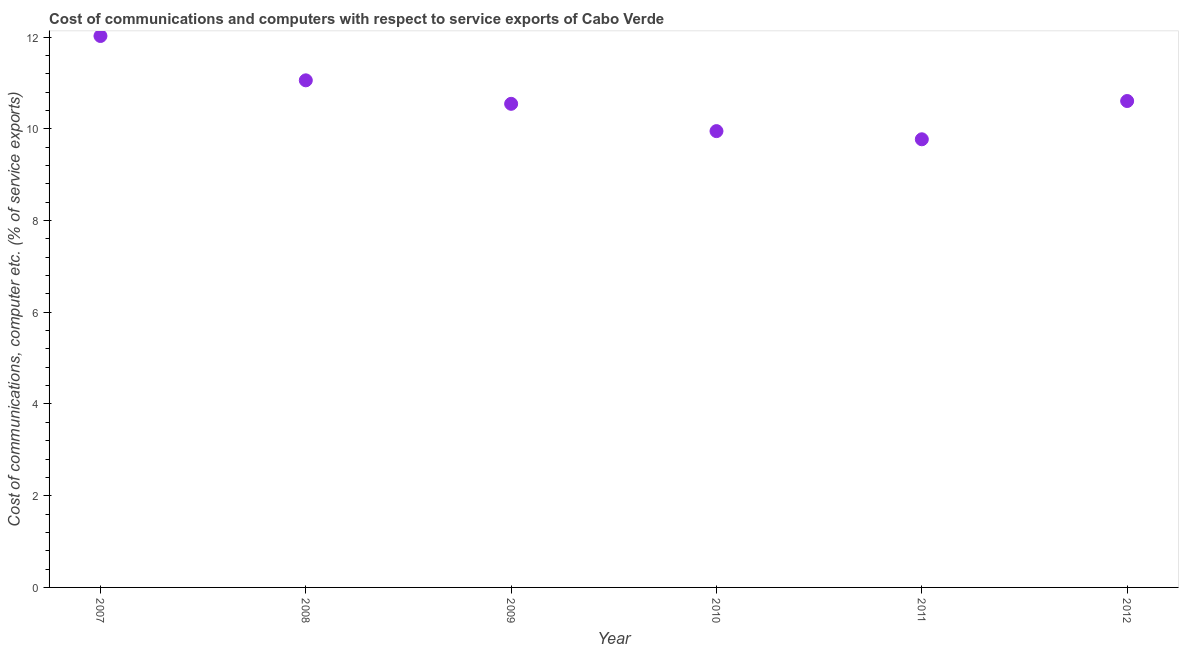What is the cost of communications and computer in 2012?
Provide a short and direct response. 10.61. Across all years, what is the maximum cost of communications and computer?
Keep it short and to the point. 12.02. Across all years, what is the minimum cost of communications and computer?
Offer a very short reply. 9.77. In which year was the cost of communications and computer minimum?
Offer a terse response. 2011. What is the sum of the cost of communications and computer?
Make the answer very short. 63.96. What is the difference between the cost of communications and computer in 2010 and 2012?
Your answer should be compact. -0.66. What is the average cost of communications and computer per year?
Your response must be concise. 10.66. What is the median cost of communications and computer?
Provide a short and direct response. 10.58. In how many years, is the cost of communications and computer greater than 8 %?
Give a very brief answer. 6. What is the ratio of the cost of communications and computer in 2007 to that in 2011?
Give a very brief answer. 1.23. What is the difference between the highest and the second highest cost of communications and computer?
Keep it short and to the point. 0.97. What is the difference between the highest and the lowest cost of communications and computer?
Offer a very short reply. 2.25. In how many years, is the cost of communications and computer greater than the average cost of communications and computer taken over all years?
Offer a very short reply. 2. How many dotlines are there?
Make the answer very short. 1. Are the values on the major ticks of Y-axis written in scientific E-notation?
Your answer should be very brief. No. Does the graph contain any zero values?
Your answer should be very brief. No. Does the graph contain grids?
Your response must be concise. No. What is the title of the graph?
Provide a succinct answer. Cost of communications and computers with respect to service exports of Cabo Verde. What is the label or title of the Y-axis?
Make the answer very short. Cost of communications, computer etc. (% of service exports). What is the Cost of communications, computer etc. (% of service exports) in 2007?
Give a very brief answer. 12.02. What is the Cost of communications, computer etc. (% of service exports) in 2008?
Your response must be concise. 11.06. What is the Cost of communications, computer etc. (% of service exports) in 2009?
Ensure brevity in your answer.  10.55. What is the Cost of communications, computer etc. (% of service exports) in 2010?
Offer a very short reply. 9.95. What is the Cost of communications, computer etc. (% of service exports) in 2011?
Provide a succinct answer. 9.77. What is the Cost of communications, computer etc. (% of service exports) in 2012?
Your response must be concise. 10.61. What is the difference between the Cost of communications, computer etc. (% of service exports) in 2007 and 2008?
Keep it short and to the point. 0.97. What is the difference between the Cost of communications, computer etc. (% of service exports) in 2007 and 2009?
Your answer should be very brief. 1.48. What is the difference between the Cost of communications, computer etc. (% of service exports) in 2007 and 2010?
Ensure brevity in your answer.  2.07. What is the difference between the Cost of communications, computer etc. (% of service exports) in 2007 and 2011?
Keep it short and to the point. 2.25. What is the difference between the Cost of communications, computer etc. (% of service exports) in 2007 and 2012?
Give a very brief answer. 1.42. What is the difference between the Cost of communications, computer etc. (% of service exports) in 2008 and 2009?
Your answer should be very brief. 0.51. What is the difference between the Cost of communications, computer etc. (% of service exports) in 2008 and 2010?
Provide a short and direct response. 1.11. What is the difference between the Cost of communications, computer etc. (% of service exports) in 2008 and 2011?
Your response must be concise. 1.29. What is the difference between the Cost of communications, computer etc. (% of service exports) in 2008 and 2012?
Make the answer very short. 0.45. What is the difference between the Cost of communications, computer etc. (% of service exports) in 2009 and 2010?
Ensure brevity in your answer.  0.6. What is the difference between the Cost of communications, computer etc. (% of service exports) in 2009 and 2011?
Provide a short and direct response. 0.77. What is the difference between the Cost of communications, computer etc. (% of service exports) in 2009 and 2012?
Your response must be concise. -0.06. What is the difference between the Cost of communications, computer etc. (% of service exports) in 2010 and 2011?
Ensure brevity in your answer.  0.18. What is the difference between the Cost of communications, computer etc. (% of service exports) in 2010 and 2012?
Ensure brevity in your answer.  -0.66. What is the difference between the Cost of communications, computer etc. (% of service exports) in 2011 and 2012?
Offer a terse response. -0.83. What is the ratio of the Cost of communications, computer etc. (% of service exports) in 2007 to that in 2008?
Give a very brief answer. 1.09. What is the ratio of the Cost of communications, computer etc. (% of service exports) in 2007 to that in 2009?
Provide a succinct answer. 1.14. What is the ratio of the Cost of communications, computer etc. (% of service exports) in 2007 to that in 2010?
Your response must be concise. 1.21. What is the ratio of the Cost of communications, computer etc. (% of service exports) in 2007 to that in 2011?
Keep it short and to the point. 1.23. What is the ratio of the Cost of communications, computer etc. (% of service exports) in 2007 to that in 2012?
Provide a succinct answer. 1.13. What is the ratio of the Cost of communications, computer etc. (% of service exports) in 2008 to that in 2009?
Keep it short and to the point. 1.05. What is the ratio of the Cost of communications, computer etc. (% of service exports) in 2008 to that in 2010?
Offer a very short reply. 1.11. What is the ratio of the Cost of communications, computer etc. (% of service exports) in 2008 to that in 2011?
Make the answer very short. 1.13. What is the ratio of the Cost of communications, computer etc. (% of service exports) in 2008 to that in 2012?
Provide a succinct answer. 1.04. What is the ratio of the Cost of communications, computer etc. (% of service exports) in 2009 to that in 2010?
Offer a very short reply. 1.06. What is the ratio of the Cost of communications, computer etc. (% of service exports) in 2009 to that in 2011?
Offer a terse response. 1.08. What is the ratio of the Cost of communications, computer etc. (% of service exports) in 2009 to that in 2012?
Keep it short and to the point. 0.99. What is the ratio of the Cost of communications, computer etc. (% of service exports) in 2010 to that in 2011?
Your response must be concise. 1.02. What is the ratio of the Cost of communications, computer etc. (% of service exports) in 2010 to that in 2012?
Your answer should be compact. 0.94. What is the ratio of the Cost of communications, computer etc. (% of service exports) in 2011 to that in 2012?
Make the answer very short. 0.92. 